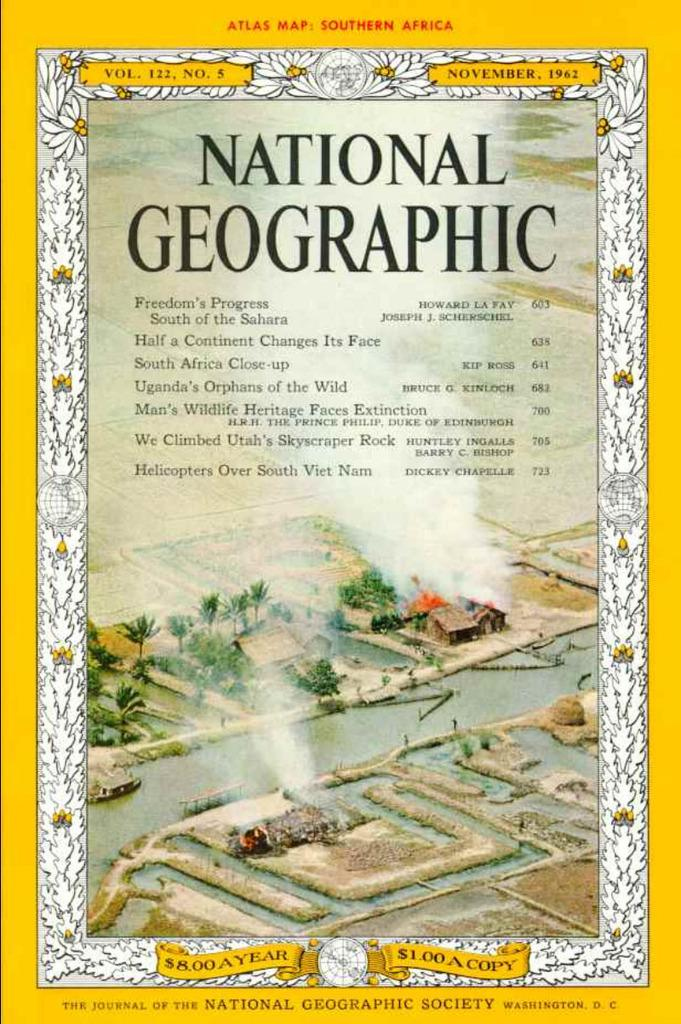<image>
Describe the image concisely. a National Geographic book that has a little village on it 